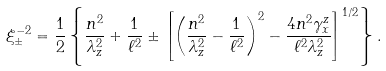<formula> <loc_0><loc_0><loc_500><loc_500>\xi ^ { - 2 } _ { \pm } = \frac { 1 } { 2 } \left \{ \frac { n ^ { 2 } } { \lambda _ { z } ^ { 2 } } + \frac { 1 } { \ell ^ { 2 } } \pm \left [ \left ( \frac { n ^ { 2 } } { \lambda _ { z } ^ { 2 } } - \frac { 1 } { \ell ^ { 2 } } \right ) ^ { 2 } - \frac { 4 n ^ { 2 } \gamma _ { x } ^ { z } } { \ell ^ { 2 } \lambda _ { z } ^ { 2 } } \right ] ^ { 1 / 2 } \right \} .</formula> 